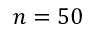Convert formula to latex. <formula><loc_0><loc_0><loc_500><loc_500>n = 5 0</formula> 